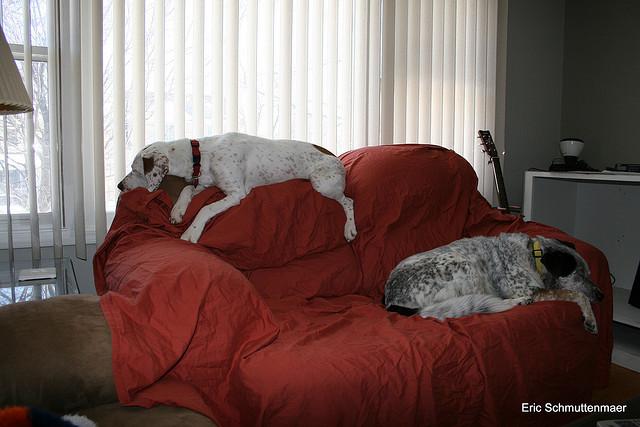What music instrument is next to the sofa?
Write a very short answer. Guitar. Are the dogs wearing collars?
Keep it brief. Yes. Which animal is wearing bows?
Write a very short answer. None. Are the blinds open?
Quick response, please. Yes. 